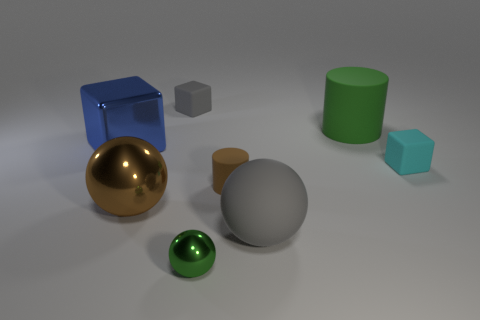Add 1 blue cubes. How many objects exist? 9 Subtract all spheres. How many objects are left? 5 Subtract 0 yellow cubes. How many objects are left? 8 Subtract all gray objects. Subtract all big blue objects. How many objects are left? 5 Add 6 brown cylinders. How many brown cylinders are left? 7 Add 8 tiny balls. How many tiny balls exist? 9 